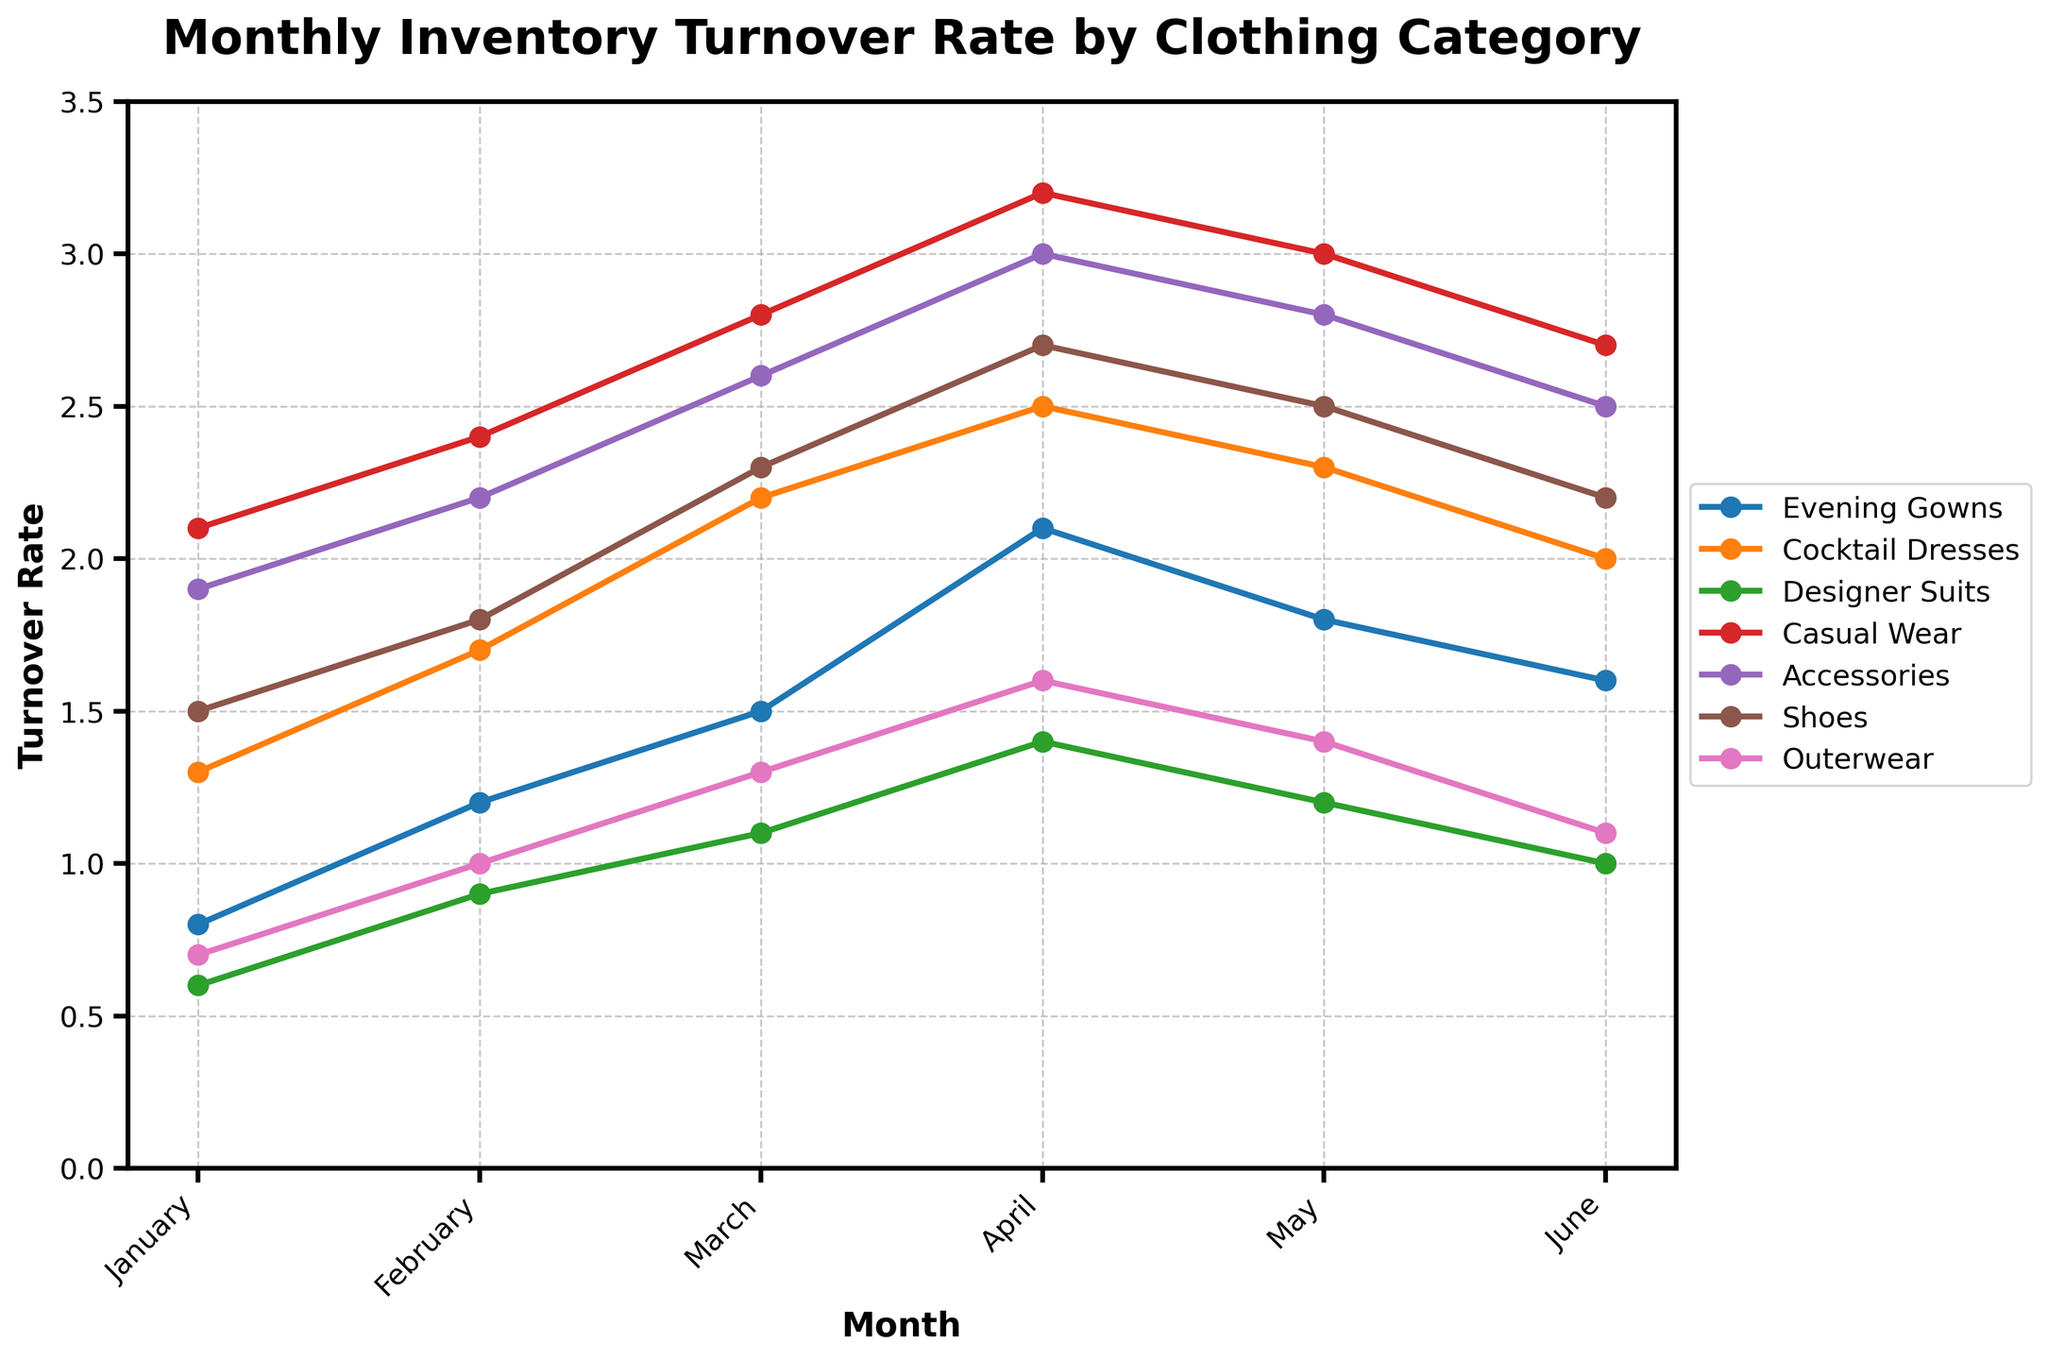What is the inventory turnover rate for Evening Gowns in March? To find the turnover rate for Evening Gowns in March, refer to the data point for the Evening Gowns line at the month of March on the x-axis.
Answer: 1.5 Which category had the highest turnover rate in April? To find the category with the highest turnover rate in April, compare the heights of the lines' data markers for April and identify the highest one.
Answer: Casual Wear What is the total inventory turnover rate for Cocktail Dresses from January to June? Sum the turnover rates of Cocktail Dresses from January to June: 1.3 + 1.7 + 2.2 + 2.5 + 2.3 + 2.0.
Answer: 12.0 Did the turnover rate for Accessories ever exceed 3 across the months? Compare the data markers for Accessories across all months to see if any exceed the turnover rate of 3.
Answer: No How does the April turnover rate for Shoes compare to that of Designer Suits? Check the values for Shoes and Designer Suits in April and compare them. Shoes: 2.7, Designer Suits: 1.4.
Answer: Shoes is higher What is the average monthly turnover rate for Casual Wear from January to June? Add up the turnover rates for Casual Wear from January to June and then divide by the number of months: (2.1 + 2.4 + 2.8 + 3.2 + 3.0 + 2.7) / 6.
Answer: 2.7 Which category showed the most consistent (least fluctuating) turnover rate over the six months? Examine the fluctuation in turnover rates for each category over the six months and determine the one with the smallest range or variance in values.
Answer: Designer Suits Was there any month where the turnover rate for Outerwear was higher than the rate for Evening Gowns? Compare the monthly turnover rates for Outerwear and Evening Gowns to check if Outerwear’s rate surpasses Evening Gowns in any month.
Answer: No Identify the month where Casual Wear had its highest turnover rate and provide the rate. Locate the peak of Casual Wear’s turnover rate on the graph and determine the respective month and value.
Answer: April, 3.2 Which category had the lowest turnover rate in January and what was the value? Find the line corresponding to the lowest data point among all categories for the month of January.
Answer: Designer Suits, 0.6 